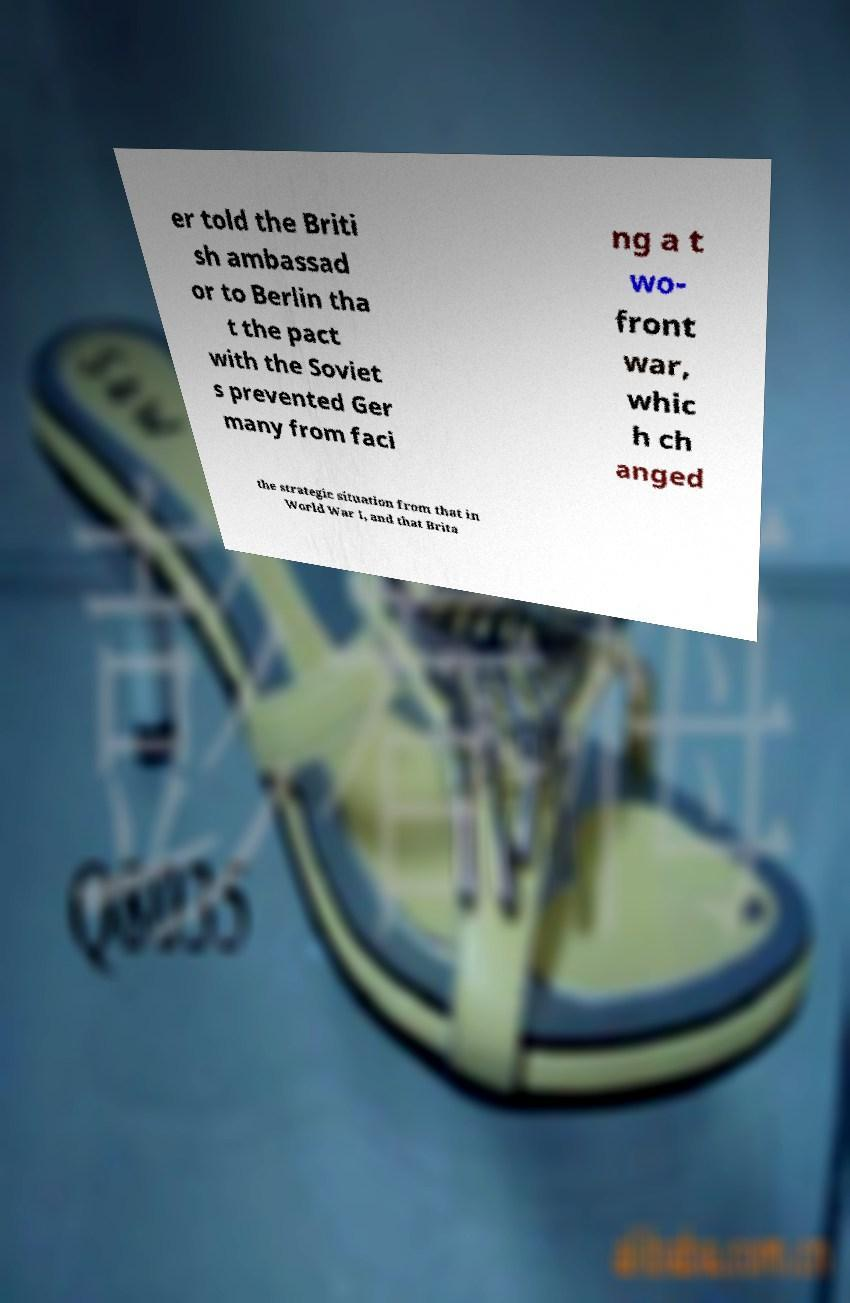For documentation purposes, I need the text within this image transcribed. Could you provide that? er told the Briti sh ambassad or to Berlin tha t the pact with the Soviet s prevented Ger many from faci ng a t wo- front war, whic h ch anged the strategic situation from that in World War I, and that Brita 